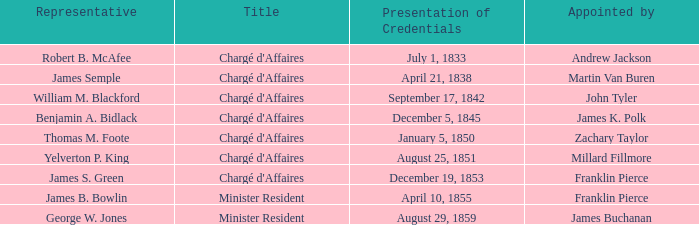What title possesses a conclusion of mission for august 13, 1854? Chargé d'Affaires. 